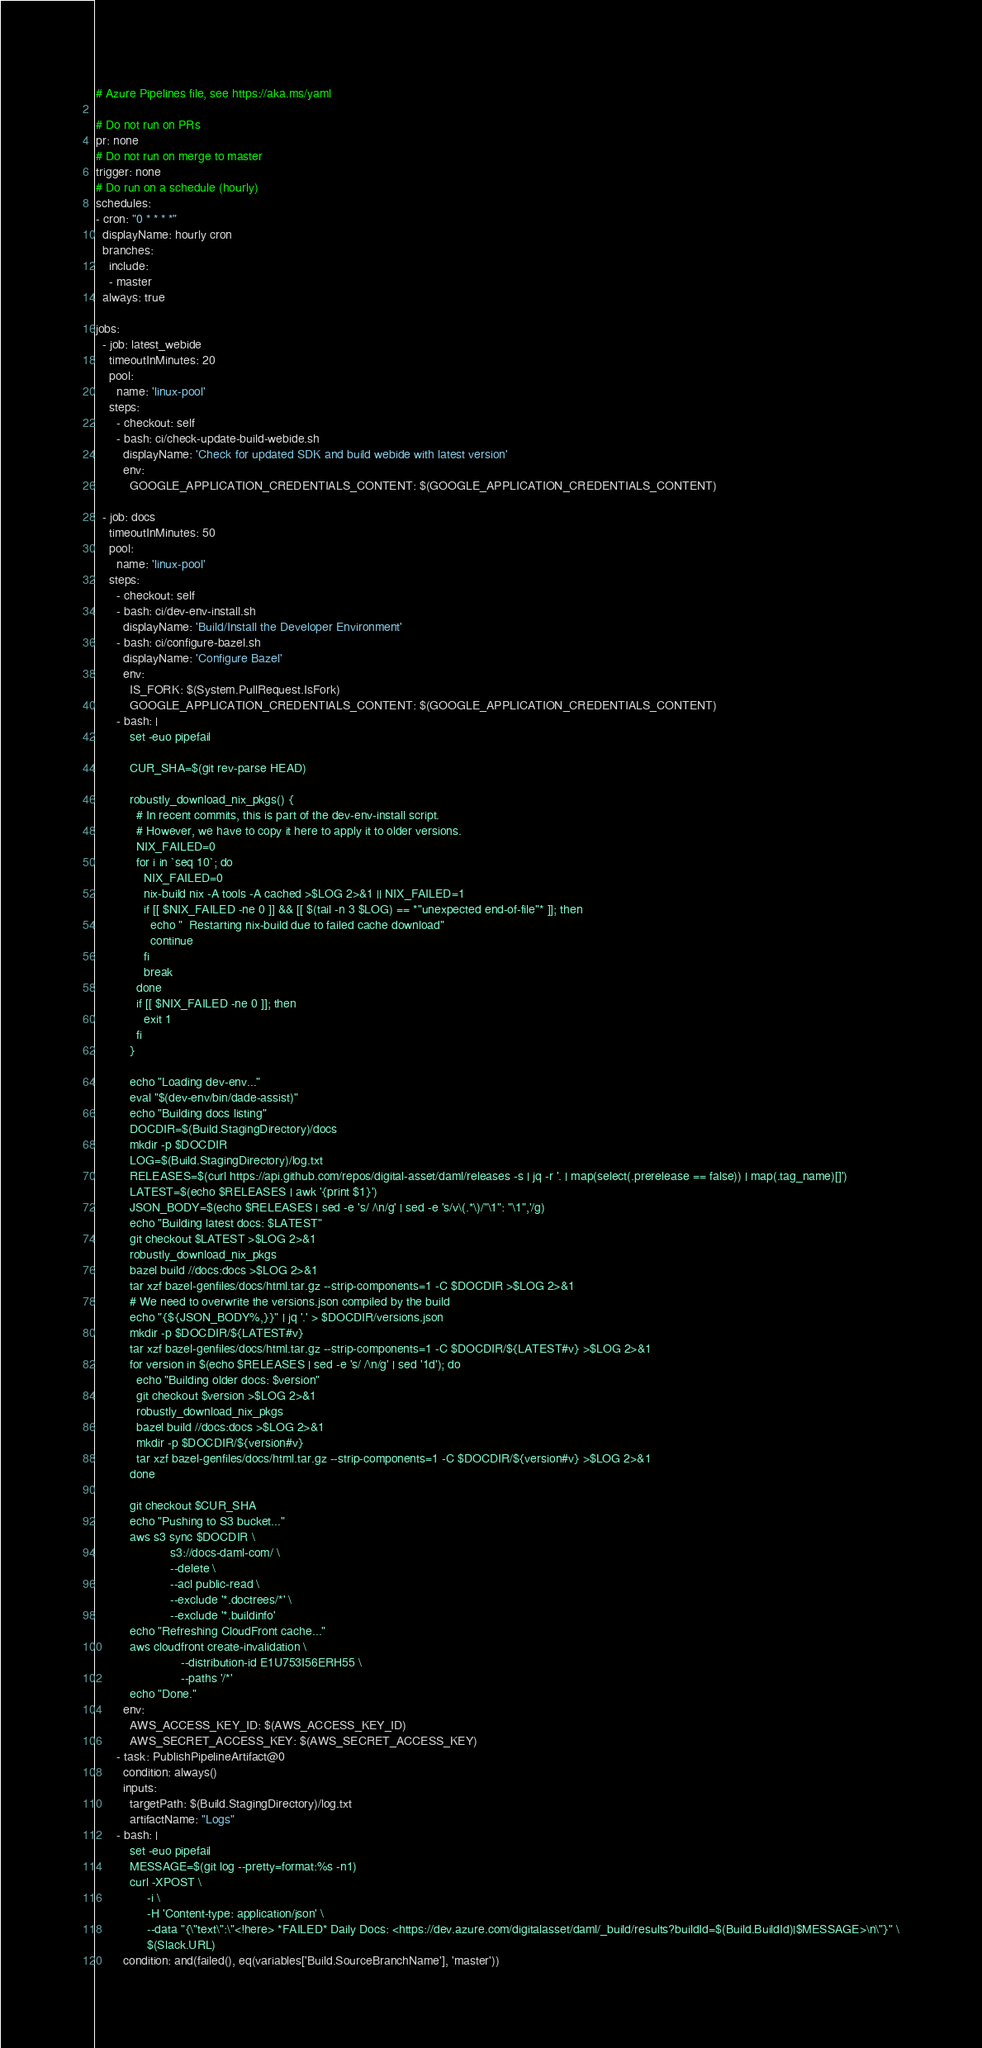<code> <loc_0><loc_0><loc_500><loc_500><_YAML_># Azure Pipelines file, see https://aka.ms/yaml

# Do not run on PRs
pr: none
# Do not run on merge to master
trigger: none
# Do run on a schedule (hourly)
schedules:
- cron: "0 * * * *"
  displayName: hourly cron
  branches:
    include:
    - master
  always: true

jobs:
  - job: latest_webide
    timeoutInMinutes: 20
    pool:
      name: 'linux-pool'
    steps:
      - checkout: self
      - bash: ci/check-update-build-webide.sh
        displayName: 'Check for updated SDK and build webide with latest version'
        env:
          GOOGLE_APPLICATION_CREDENTIALS_CONTENT: $(GOOGLE_APPLICATION_CREDENTIALS_CONTENT)

  - job: docs
    timeoutInMinutes: 50
    pool:
      name: 'linux-pool'
    steps:
      - checkout: self
      - bash: ci/dev-env-install.sh
        displayName: 'Build/Install the Developer Environment'
      - bash: ci/configure-bazel.sh
        displayName: 'Configure Bazel'
        env:
          IS_FORK: $(System.PullRequest.IsFork)
          GOOGLE_APPLICATION_CREDENTIALS_CONTENT: $(GOOGLE_APPLICATION_CREDENTIALS_CONTENT)
      - bash: |
          set -euo pipefail

          CUR_SHA=$(git rev-parse HEAD)

          robustly_download_nix_pkgs() {
            # In recent commits, this is part of the dev-env-install script.
            # However, we have to copy it here to apply it to older versions.
            NIX_FAILED=0
            for i in `seq 10`; do
              NIX_FAILED=0
              nix-build nix -A tools -A cached >$LOG 2>&1 || NIX_FAILED=1
              if [[ $NIX_FAILED -ne 0 ]] && [[ $(tail -n 3 $LOG) == *"unexpected end-of-file"* ]]; then
                echo "  Restarting nix-build due to failed cache download"
                continue
              fi
              break
            done
            if [[ $NIX_FAILED -ne 0 ]]; then
              exit 1
            fi
          }

          echo "Loading dev-env..."
          eval "$(dev-env/bin/dade-assist)"
          echo "Building docs listing"
          DOCDIR=$(Build.StagingDirectory)/docs
          mkdir -p $DOCDIR
          LOG=$(Build.StagingDirectory)/log.txt
          RELEASES=$(curl https://api.github.com/repos/digital-asset/daml/releases -s | jq -r '. | map(select(.prerelease == false)) | map(.tag_name)[]')
          LATEST=$(echo $RELEASES | awk '{print $1}')
          JSON_BODY=$(echo $RELEASES | sed -e 's/ /\n/g' | sed -e 's/v\(.*\)/"\1": "\1",'/g)
          echo "Building latest docs: $LATEST"
          git checkout $LATEST >$LOG 2>&1
          robustly_download_nix_pkgs
          bazel build //docs:docs >$LOG 2>&1
          tar xzf bazel-genfiles/docs/html.tar.gz --strip-components=1 -C $DOCDIR >$LOG 2>&1
          # We need to overwrite the versions.json compiled by the build
          echo "{${JSON_BODY%,}}" | jq '.' > $DOCDIR/versions.json
          mkdir -p $DOCDIR/${LATEST#v}
          tar xzf bazel-genfiles/docs/html.tar.gz --strip-components=1 -C $DOCDIR/${LATEST#v} >$LOG 2>&1
          for version in $(echo $RELEASES | sed -e 's/ /\n/g' | sed '1d'); do
            echo "Building older docs: $version"
            git checkout $version >$LOG 2>&1
            robustly_download_nix_pkgs
            bazel build //docs:docs >$LOG 2>&1
            mkdir -p $DOCDIR/${version#v}
            tar xzf bazel-genfiles/docs/html.tar.gz --strip-components=1 -C $DOCDIR/${version#v} >$LOG 2>&1
          done

          git checkout $CUR_SHA
          echo "Pushing to S3 bucket..."
          aws s3 sync $DOCDIR \
                      s3://docs-daml-com/ \
                      --delete \
                      --acl public-read \
                      --exclude '*.doctrees/*' \
                      --exclude '*.buildinfo'
          echo "Refreshing CloudFront cache..."
          aws cloudfront create-invalidation \
                         --distribution-id E1U753I56ERH55 \
                         --paths '/*'
          echo "Done."
        env:
          AWS_ACCESS_KEY_ID: $(AWS_ACCESS_KEY_ID)
          AWS_SECRET_ACCESS_KEY: $(AWS_SECRET_ACCESS_KEY)
      - task: PublishPipelineArtifact@0
        condition: always()
        inputs:
          targetPath: $(Build.StagingDirectory)/log.txt
          artifactName: "Logs"
      - bash: |
          set -euo pipefail
          MESSAGE=$(git log --pretty=format:%s -n1)
          curl -XPOST \
               -i \
               -H 'Content-type: application/json' \
               --data "{\"text\":\"<!here> *FAILED* Daily Docs: <https://dev.azure.com/digitalasset/daml/_build/results?buildId=$(Build.BuildId)|$MESSAGE>\n\"}" \
               $(Slack.URL)
        condition: and(failed(), eq(variables['Build.SourceBranchName'], 'master'))
</code> 